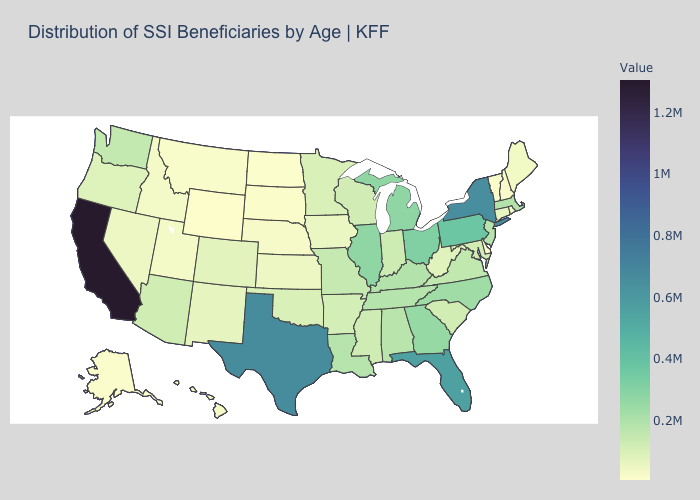Does Iowa have the lowest value in the USA?
Write a very short answer. No. Among the states that border New Jersey , which have the highest value?
Be succinct. New York. Is the legend a continuous bar?
Answer briefly. Yes. Does New York have the highest value in the Northeast?
Answer briefly. Yes. Does Ohio have the highest value in the MidWest?
Be succinct. Yes. Among the states that border Minnesota , which have the highest value?
Answer briefly. Wisconsin. Among the states that border New Hampshire , does Massachusetts have the highest value?
Keep it brief. Yes. 